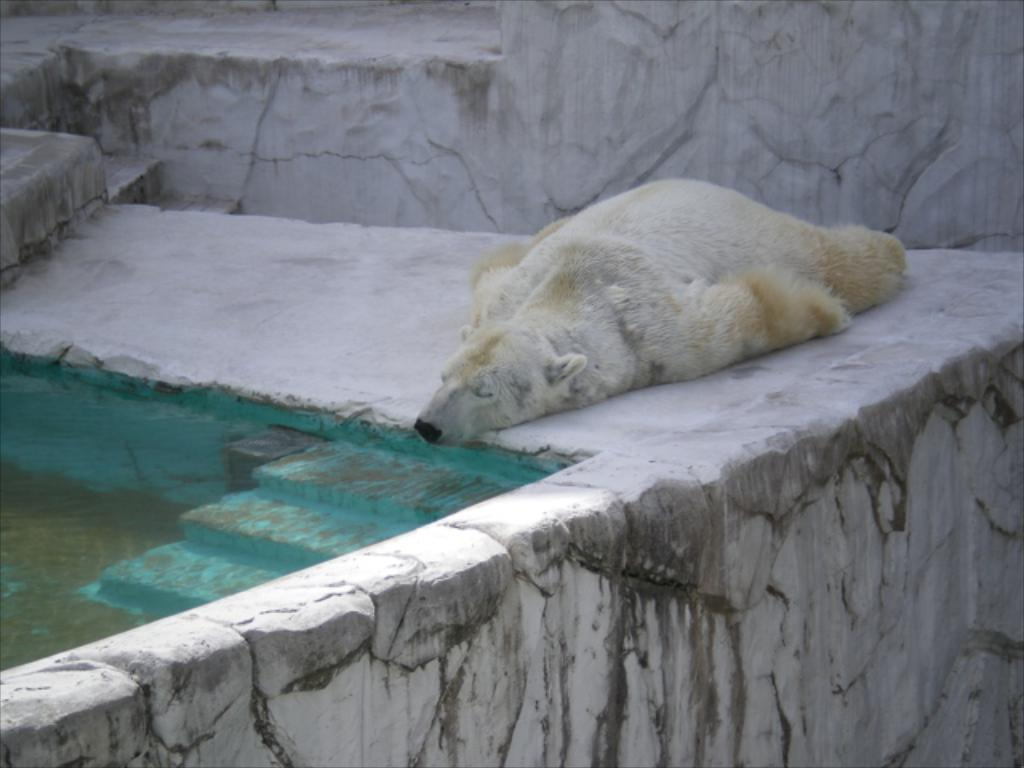What animal is present in the image? There is a polar bear in the image. What is the polar bear doing in the image? The polar bear is sleeping on the floor. What can be seen in the background of the image? There is a wall in the background of the image. What is visible on the left side of the image? There is water visible on the left side of the image. What type of laborer is working on the edge of the frame in the image? There is no laborer or frame present in the image; it features a polar bear sleeping on the floor. 